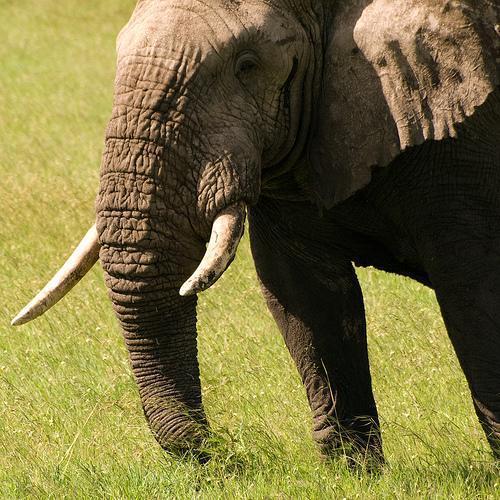How many tusks are shown?
Give a very brief answer. 2. How many ears are shown?
Give a very brief answer. 1. How many elephants are in the photo?
Give a very brief answer. 1. How many tusks does the animal have?
Give a very brief answer. 2. How many eyes are visible?
Give a very brief answer. 1. 